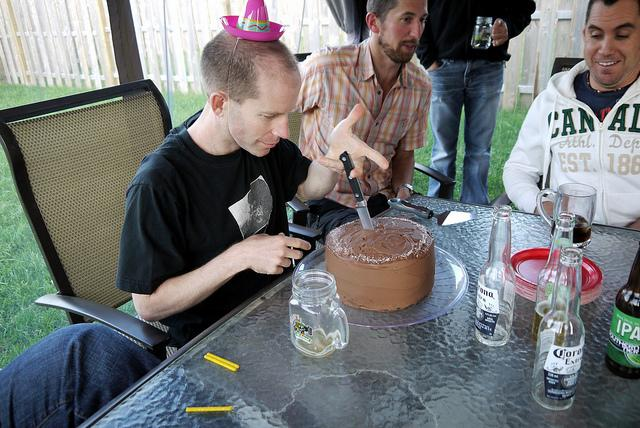What is in the cake? Please explain your reasoning. knife. The cake has a knife. 